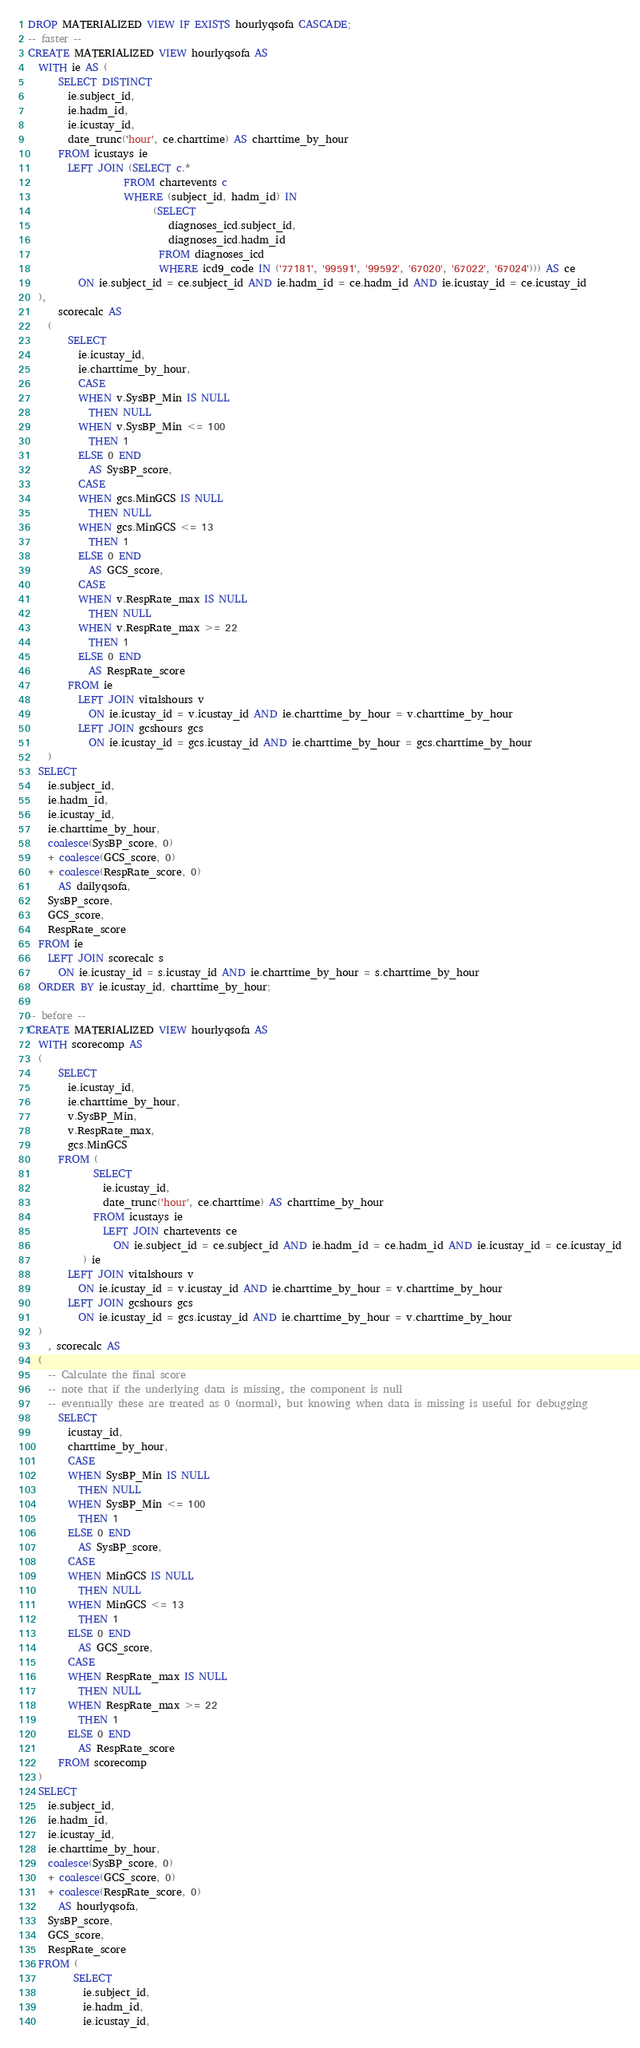Convert code to text. <code><loc_0><loc_0><loc_500><loc_500><_SQL_>DROP MATERIALIZED VIEW IF EXISTS hourlyqsofa CASCADE;
-- faster --
CREATE MATERIALIZED VIEW hourlyqsofa AS
  WITH ie AS (
      SELECT DISTINCT
        ie.subject_id,
        ie.hadm_id,
        ie.icustay_id,
        date_trunc('hour', ce.charttime) AS charttime_by_hour
      FROM icustays ie
        LEFT JOIN (SELECT c.*
                   FROM chartevents c
                   WHERE (subject_id, hadm_id) IN
                         (SELECT
                            diagnoses_icd.subject_id,
                            diagnoses_icd.hadm_id
                          FROM diagnoses_icd
                          WHERE icd9_code IN ('77181', '99591', '99592', '67020', '67022', '67024'))) AS ce
          ON ie.subject_id = ce.subject_id AND ie.hadm_id = ce.hadm_id AND ie.icustay_id = ce.icustay_id
  ),
      scorecalc AS
    (
        SELECT
          ie.icustay_id,
          ie.charttime_by_hour,
          CASE
          WHEN v.SysBP_Min IS NULL
            THEN NULL
          WHEN v.SysBP_Min <= 100
            THEN 1
          ELSE 0 END
            AS SysBP_score,
          CASE
          WHEN gcs.MinGCS IS NULL
            THEN NULL
          WHEN gcs.MinGCS <= 13
            THEN 1
          ELSE 0 END
            AS GCS_score,
          CASE
          WHEN v.RespRate_max IS NULL
            THEN NULL
          WHEN v.RespRate_max >= 22
            THEN 1
          ELSE 0 END
            AS RespRate_score
        FROM ie
          LEFT JOIN vitalshours v
            ON ie.icustay_id = v.icustay_id AND ie.charttime_by_hour = v.charttime_by_hour
          LEFT JOIN gcshours gcs
            ON ie.icustay_id = gcs.icustay_id AND ie.charttime_by_hour = gcs.charttime_by_hour
    )
  SELECT
    ie.subject_id,
    ie.hadm_id,
    ie.icustay_id,
    ie.charttime_by_hour,
    coalesce(SysBP_score, 0)
    + coalesce(GCS_score, 0)
    + coalesce(RespRate_score, 0)
      AS dailyqsofa,
    SysBP_score,
    GCS_score,
    RespRate_score
  FROM ie
    LEFT JOIN scorecalc s
      ON ie.icustay_id = s.icustay_id AND ie.charttime_by_hour = s.charttime_by_hour
  ORDER BY ie.icustay_id, charttime_by_hour;

-- before --
CREATE MATERIALIZED VIEW hourlyqsofa AS
  WITH scorecomp AS
  (
      SELECT
        ie.icustay_id,
        ie.charttime_by_hour,
        v.SysBP_Min,
        v.RespRate_max,
        gcs.MinGCS
      FROM (
             SELECT
               ie.icustay_id,
               date_trunc('hour', ce.charttime) AS charttime_by_hour
             FROM icustays ie
               LEFT JOIN chartevents ce
                 ON ie.subject_id = ce.subject_id AND ie.hadm_id = ce.hadm_id AND ie.icustay_id = ce.icustay_id
           ) ie
        LEFT JOIN vitalshours v
          ON ie.icustay_id = v.icustay_id AND ie.charttime_by_hour = v.charttime_by_hour
        LEFT JOIN gcshours gcs
          ON ie.icustay_id = gcs.icustay_id AND ie.charttime_by_hour = v.charttime_by_hour
  )
    , scorecalc AS
  (
    -- Calculate the final score
    -- note that if the underlying data is missing, the component is null
    -- eventually these are treated as 0 (normal), but knowing when data is missing is useful for debugging
      SELECT
        icustay_id,
        charttime_by_hour,
        CASE
        WHEN SysBP_Min IS NULL
          THEN NULL
        WHEN SysBP_Min <= 100
          THEN 1
        ELSE 0 END
          AS SysBP_score,
        CASE
        WHEN MinGCS IS NULL
          THEN NULL
        WHEN MinGCS <= 13
          THEN 1
        ELSE 0 END
          AS GCS_score,
        CASE
        WHEN RespRate_max IS NULL
          THEN NULL
        WHEN RespRate_max >= 22
          THEN 1
        ELSE 0 END
          AS RespRate_score
      FROM scorecomp
  )
  SELECT
    ie.subject_id,
    ie.hadm_id,
    ie.icustay_id,
    ie.charttime_by_hour,
    coalesce(SysBP_score, 0)
    + coalesce(GCS_score, 0)
    + coalesce(RespRate_score, 0)
      AS hourlyqsofa,
    SysBP_score,
    GCS_score,
    RespRate_score
  FROM (
         SELECT
           ie.subject_id,
           ie.hadm_id,
           ie.icustay_id,</code> 